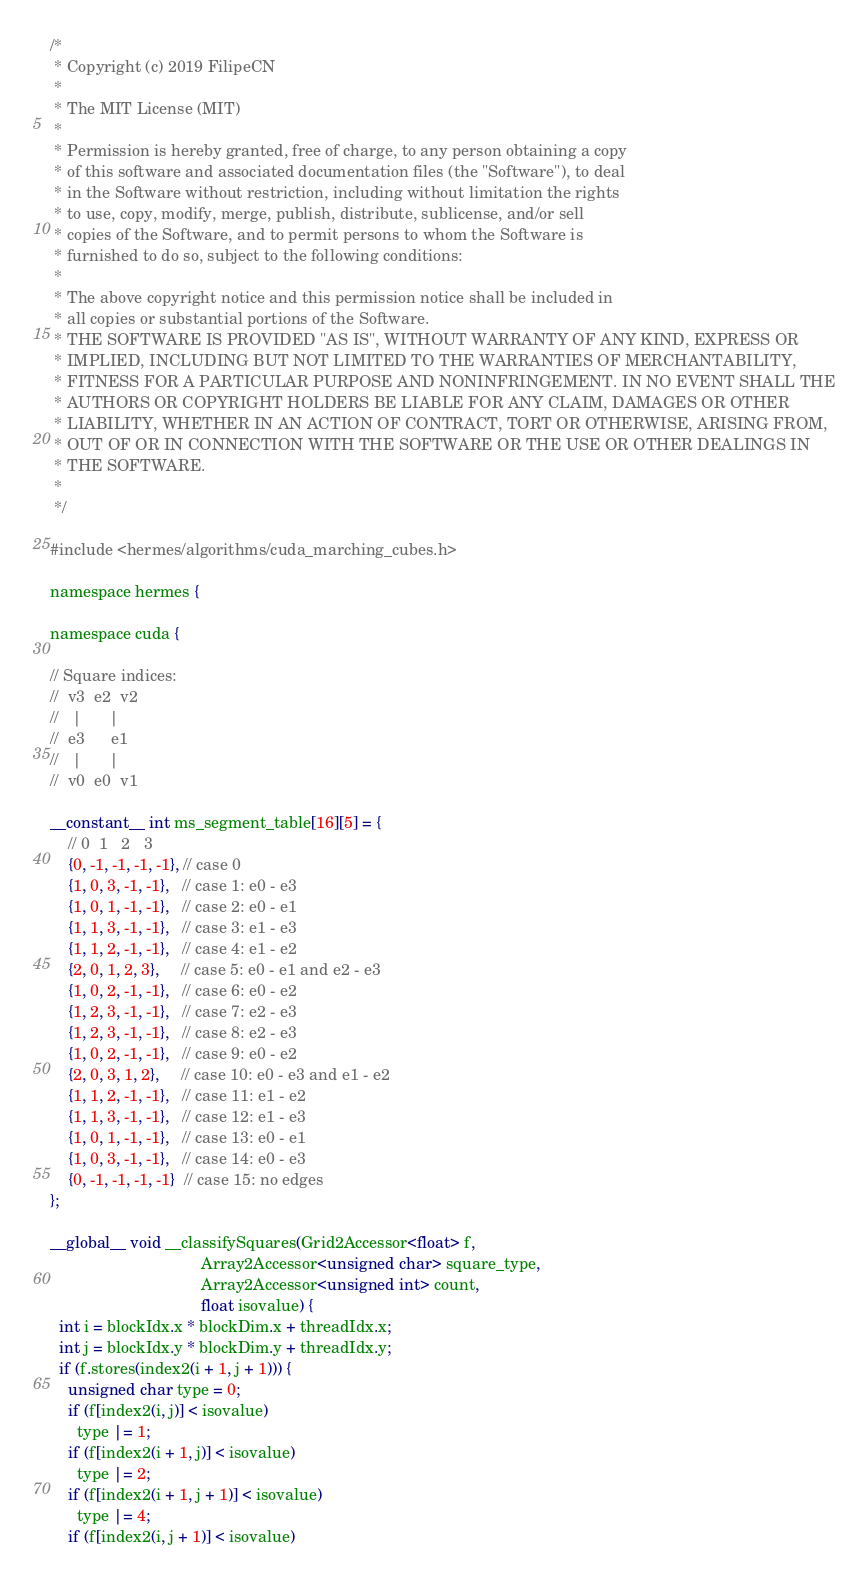Convert code to text. <code><loc_0><loc_0><loc_500><loc_500><_Cuda_>/*
 * Copyright (c) 2019 FilipeCN
 *
 * The MIT License (MIT)
 *
 * Permission is hereby granted, free of charge, to any person obtaining a copy
 * of this software and associated documentation files (the "Software"), to deal
 * in the Software without restriction, including without limitation the rights
 * to use, copy, modify, merge, publish, distribute, sublicense, and/or sell
 * copies of the Software, and to permit persons to whom the Software is
 * furnished to do so, subject to the following conditions:
 *
 * The above copyright notice and this permission notice shall be included in
 * all copies or substantial portions of the Software.
 * THE SOFTWARE IS PROVIDED "AS IS", WITHOUT WARRANTY OF ANY KIND, EXPRESS OR
 * IMPLIED, INCLUDING BUT NOT LIMITED TO THE WARRANTIES OF MERCHANTABILITY,
 * FITNESS FOR A PARTICULAR PURPOSE AND NONINFRINGEMENT. IN NO EVENT SHALL THE
 * AUTHORS OR COPYRIGHT HOLDERS BE LIABLE FOR ANY CLAIM, DAMAGES OR OTHER
 * LIABILITY, WHETHER IN AN ACTION OF CONTRACT, TORT OR OTHERWISE, ARISING FROM,
 * OUT OF OR IN CONNECTION WITH THE SOFTWARE OR THE USE OR OTHER DEALINGS IN
 * THE SOFTWARE.
 *
 */

#include <hermes/algorithms/cuda_marching_cubes.h>

namespace hermes {

namespace cuda {

// Square indices:
//  v3  e2  v2
//   |      |
//  e3      e1
//   |      |
//  v0  e0  v1

__constant__ int ms_segment_table[16][5] = {
    // 0  1   2   3
    {0, -1, -1, -1, -1}, // case 0
    {1, 0, 3, -1, -1},   // case 1: e0 - e3
    {1, 0, 1, -1, -1},   // case 2: e0 - e1
    {1, 1, 3, -1, -1},   // case 3: e1 - e3
    {1, 1, 2, -1, -1},   // case 4: e1 - e2
    {2, 0, 1, 2, 3},     // case 5: e0 - e1 and e2 - e3
    {1, 0, 2, -1, -1},   // case 6: e0 - e2
    {1, 2, 3, -1, -1},   // case 7: e2 - e3
    {1, 2, 3, -1, -1},   // case 8: e2 - e3
    {1, 0, 2, -1, -1},   // case 9: e0 - e2
    {2, 0, 3, 1, 2},     // case 10: e0 - e3 and e1 - e2
    {1, 1, 2, -1, -1},   // case 11: e1 - e2
    {1, 1, 3, -1, -1},   // case 12: e1 - e3
    {1, 0, 1, -1, -1},   // case 13: e0 - e1
    {1, 0, 3, -1, -1},   // case 14: e0 - e3
    {0, -1, -1, -1, -1}  // case 15: no edges
};

__global__ void __classifySquares(Grid2Accessor<float> f,
                                  Array2Accessor<unsigned char> square_type,
                                  Array2Accessor<unsigned int> count,
                                  float isovalue) {
  int i = blockIdx.x * blockDim.x + threadIdx.x;
  int j = blockIdx.y * blockDim.y + threadIdx.y;
  if (f.stores(index2(i + 1, j + 1))) {
    unsigned char type = 0;
    if (f[index2(i, j)] < isovalue)
      type |= 1;
    if (f[index2(i + 1, j)] < isovalue)
      type |= 2;
    if (f[index2(i + 1, j + 1)] < isovalue)
      type |= 4;
    if (f[index2(i, j + 1)] < isovalue)</code> 